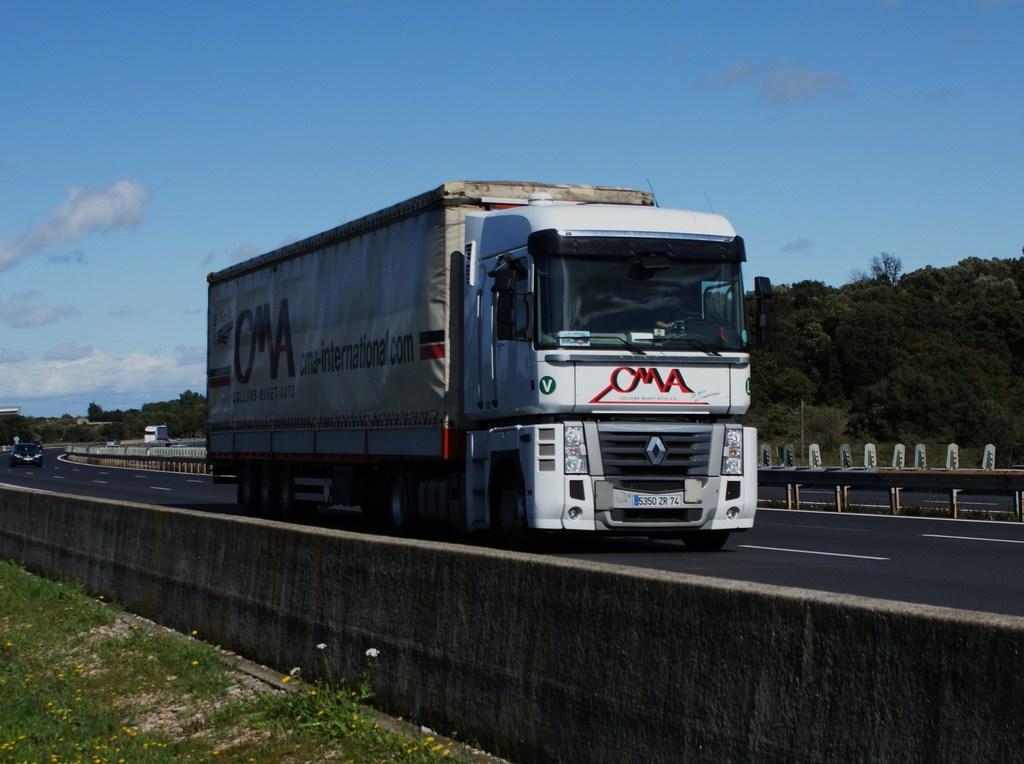How would you summarize this image in a sentence or two? In this image in the front there's grass on the ground and there are flowers. In the center there is wall and there are vehicles moving on the road. In the background there are trees, there is a metal fence and the sky is cloudy. 